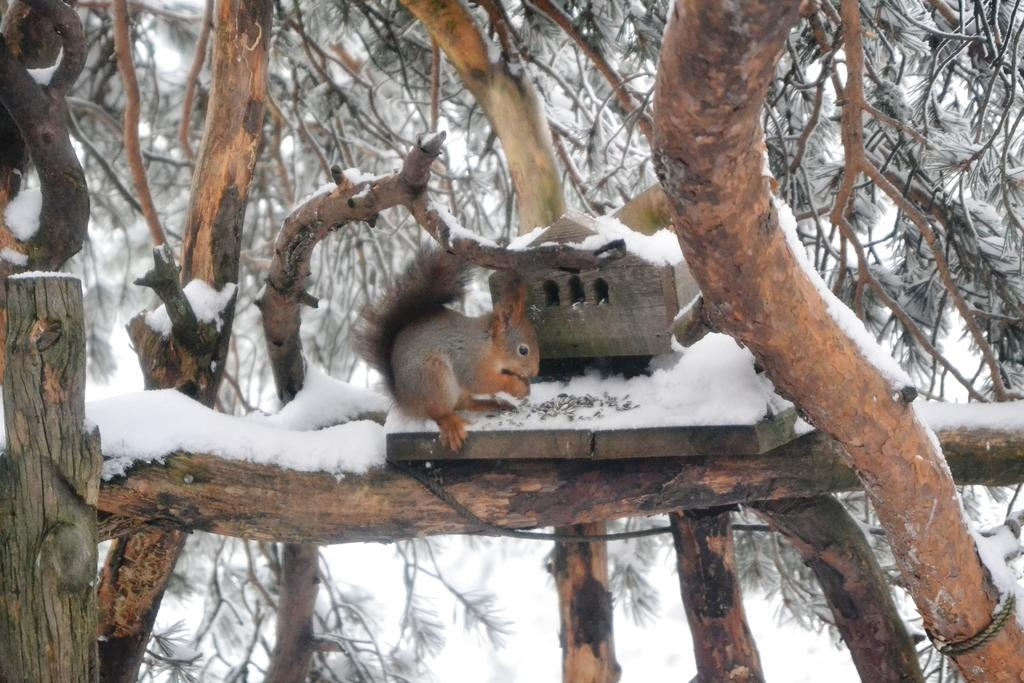What is on the wooden board in the image? There is an animal on a wooden board in the image. What type of natural environment can be seen in the image? There are trees visible in the image, which suggests a forest or wooded area. What is the weather like in the image? There is snow in the image, indicating a cold or wintery environment. What level of difficulty is the animal attempting to stretch in the image? There is no indication in the image that the animal is attempting to stretch or that there is a level of difficulty involved. 